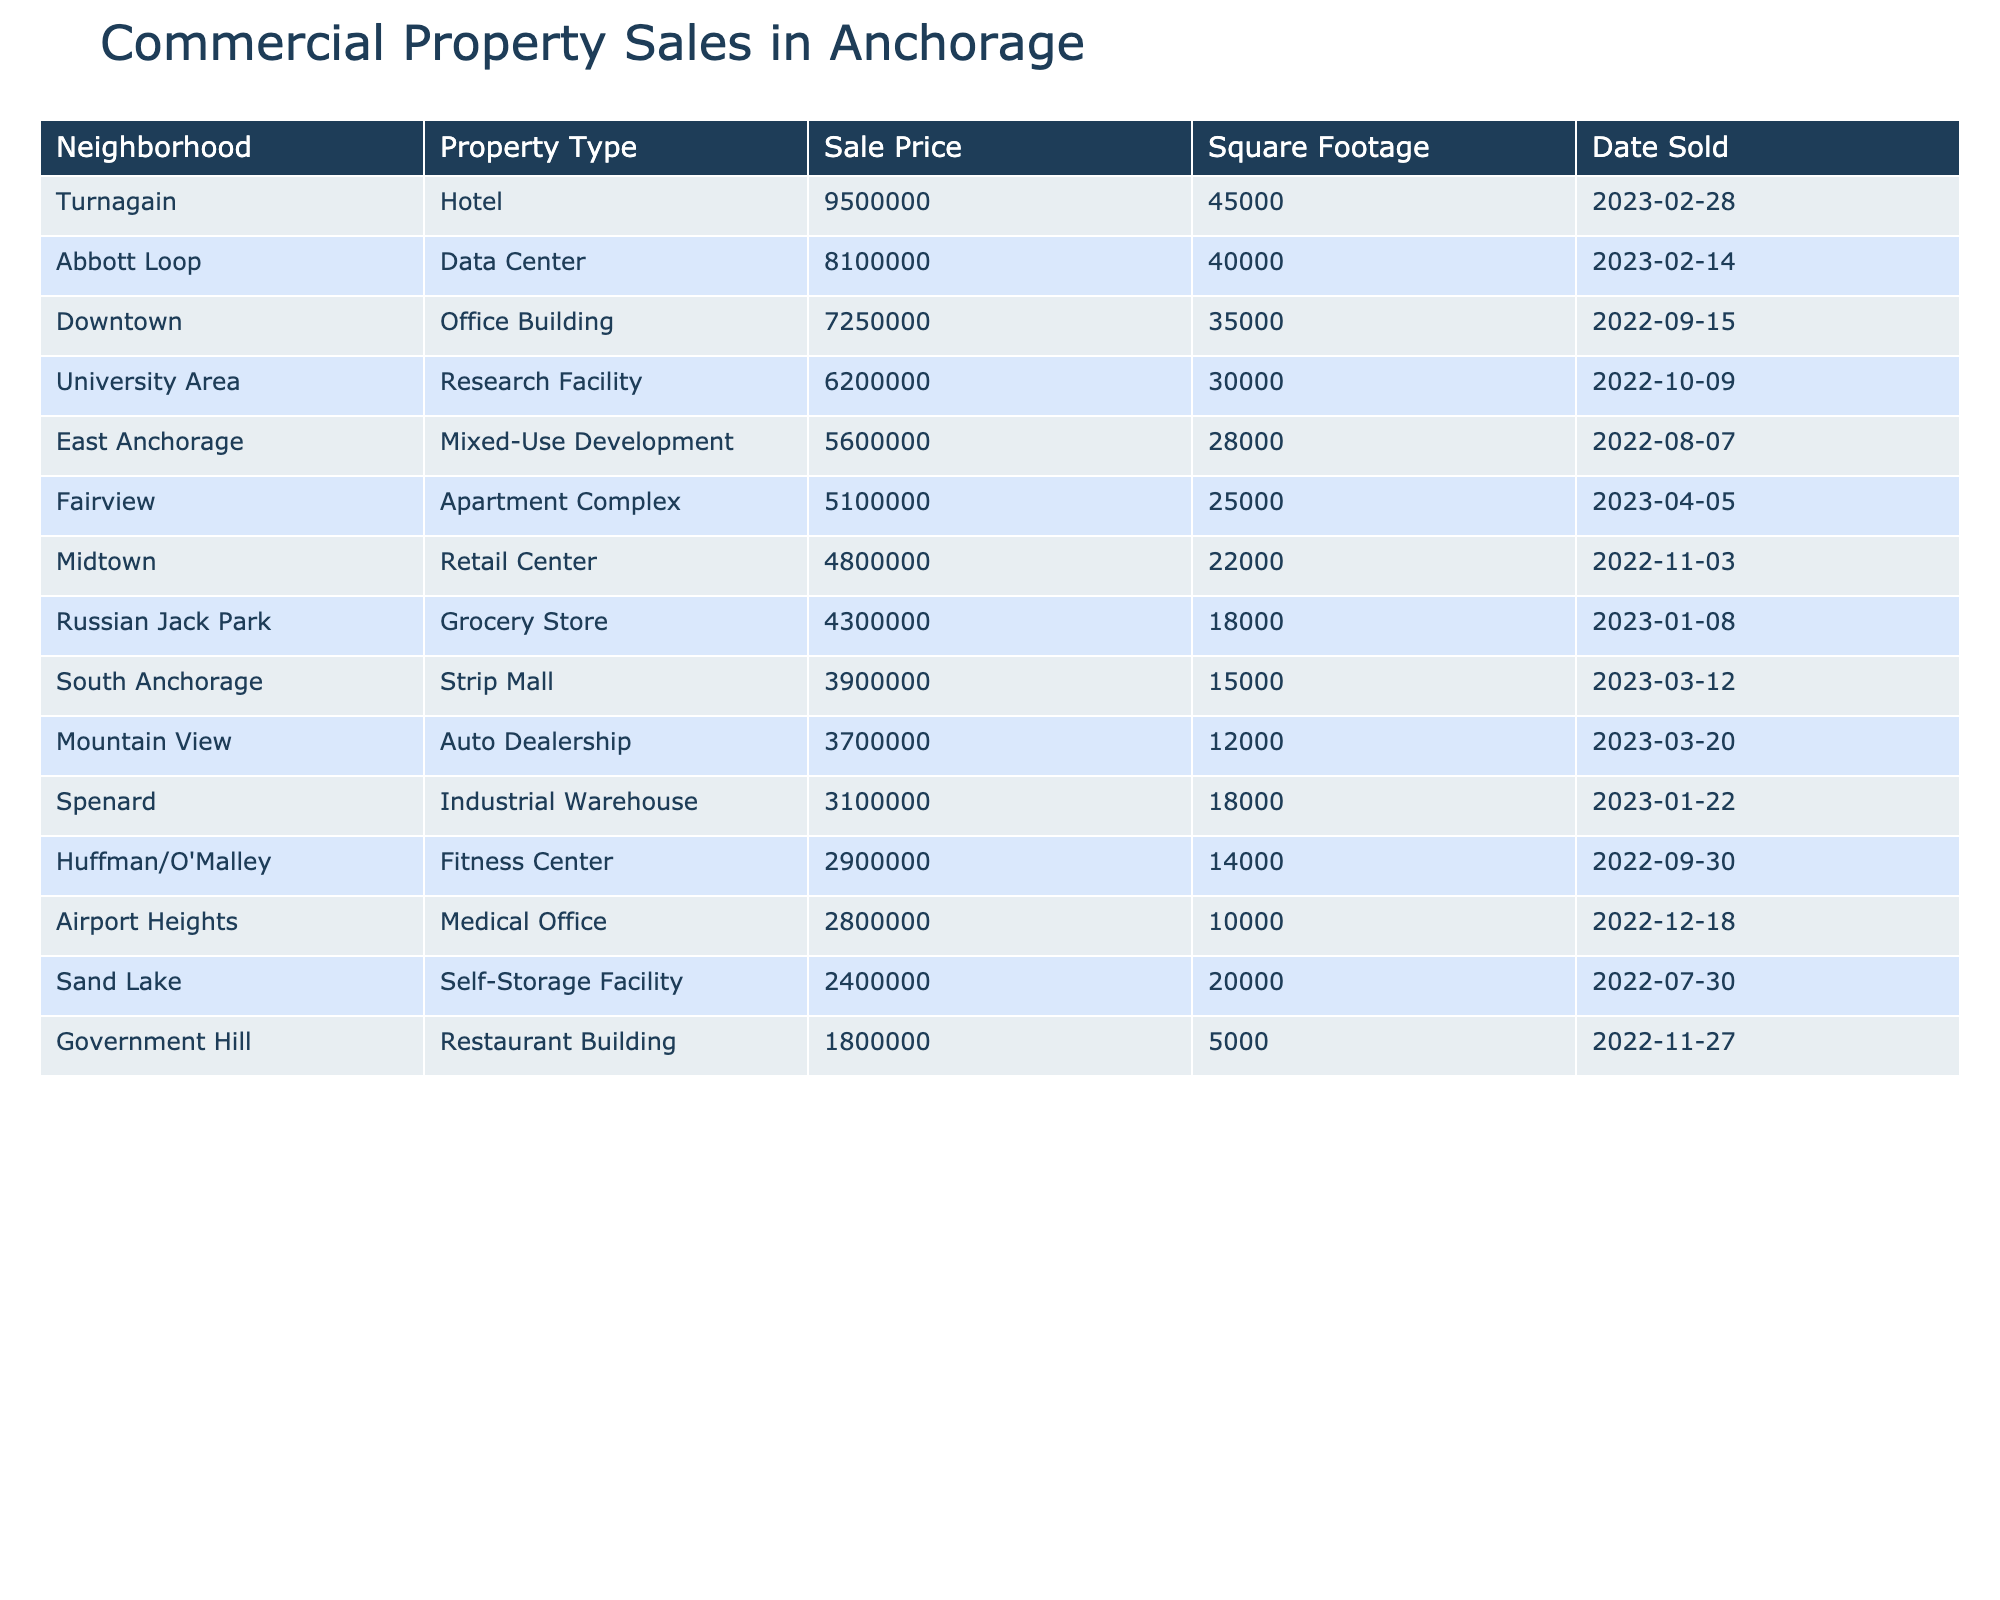What was the sale price of the most expensive commercial property? Referring to the table, I see that the most expensive property is the Hotel in Turnagain sold for $9,500,000.
Answer: $9,500,000 Which neighborhood had the lowest sale price? Looking at the table, the Restaurant Building in Government Hill has the lowest sale price at $1,800,000.
Answer: Government Hill What is the total sale price of properties in South Anchorage? The Strip Mall in South Anchorage sold for $3,900,000, which is the only property listed in that neighborhood, so the total is $3,900,000.
Answer: $3,900,000 How many different property types were sold in the past year? By scanning the table, I count 10 different property types: Office Building, Retail Center, Industrial Warehouse, Mixed-Use Development, Strip Mall, Medical Office, Hotel, Research Facility, Apartment Complex, Grocery Store, Restaurant Building, Auto Dealership, Fitness Center, and Data Center, totaling 14 property types.
Answer: 14 What is the average sale price of properties sold in Midtown? There is one property sold in Midtown—the Retail Center at $4,800,000, so the average price is $4,800,000.
Answer: $4,800,000 Which neighborhood had a property type with square footage of 45,000? The table shows that the Hotel in Turnagain has a square footage of 45,000.
Answer: Turnagain How much more expensive is the Data Center compared to the Fitness Center? The Data Center is sold for $8,100,000 and the Fitness Center for $2,900,000. The difference is $8,100,000 - $2,900,000 = $5,200,000.
Answer: $5,200,000 Is there a Mixed-Use Development in East Anchorage? Yes, the table confirms the presence of a Mixed-Use Development in East Anchorage sold for $5,600,000.
Answer: Yes What percentage of total sales in the table does the Turnagain Hotel represent? The total sale prices in the table add up to $40,050,000. The Turnagain Hotel sold for $9,500,000. The percentage is ($9,500,000 / $40,050,000) * 100 ≈ 23.7%.
Answer: 23.7% Can you list the neighborhoods that had sales above $5 million? From the table, the neighborhoods with sales above $5 million are Downtown ($7,250,000), Turnagain ($9,500,000), University Area ($6,200,000), and Abbott Loop ($8,100,000).
Answer: Downtown, Turnagain, University Area, Abbott Loop 